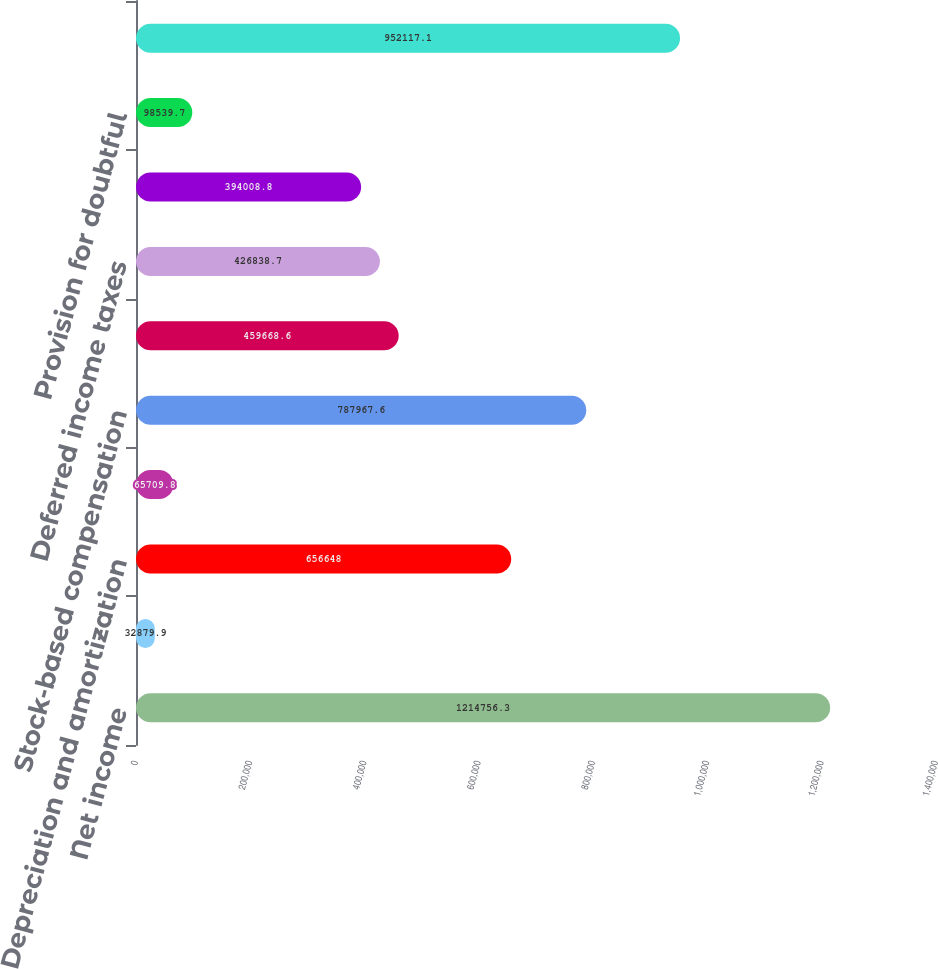Convert chart to OTSL. <chart><loc_0><loc_0><loc_500><loc_500><bar_chart><fcel>Net income<fcel>Amortization of trademark<fcel>Depreciation and amortization<fcel>(Gain) loss on disposal of<fcel>Stock-based compensation<fcel>Loss on investments net<fcel>Deferred income taxes<fcel>Tax benefit from exercise of<fcel>Provision for doubtful<fcel>Accounts receivable<nl><fcel>1.21476e+06<fcel>32879.9<fcel>656648<fcel>65709.8<fcel>787968<fcel>459669<fcel>426839<fcel>394009<fcel>98539.7<fcel>952117<nl></chart> 